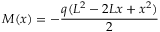<formula> <loc_0><loc_0><loc_500><loc_500>M ( x ) = - { \frac { q ( L ^ { 2 } - 2 L x + x ^ { 2 } ) } { 2 } }</formula> 